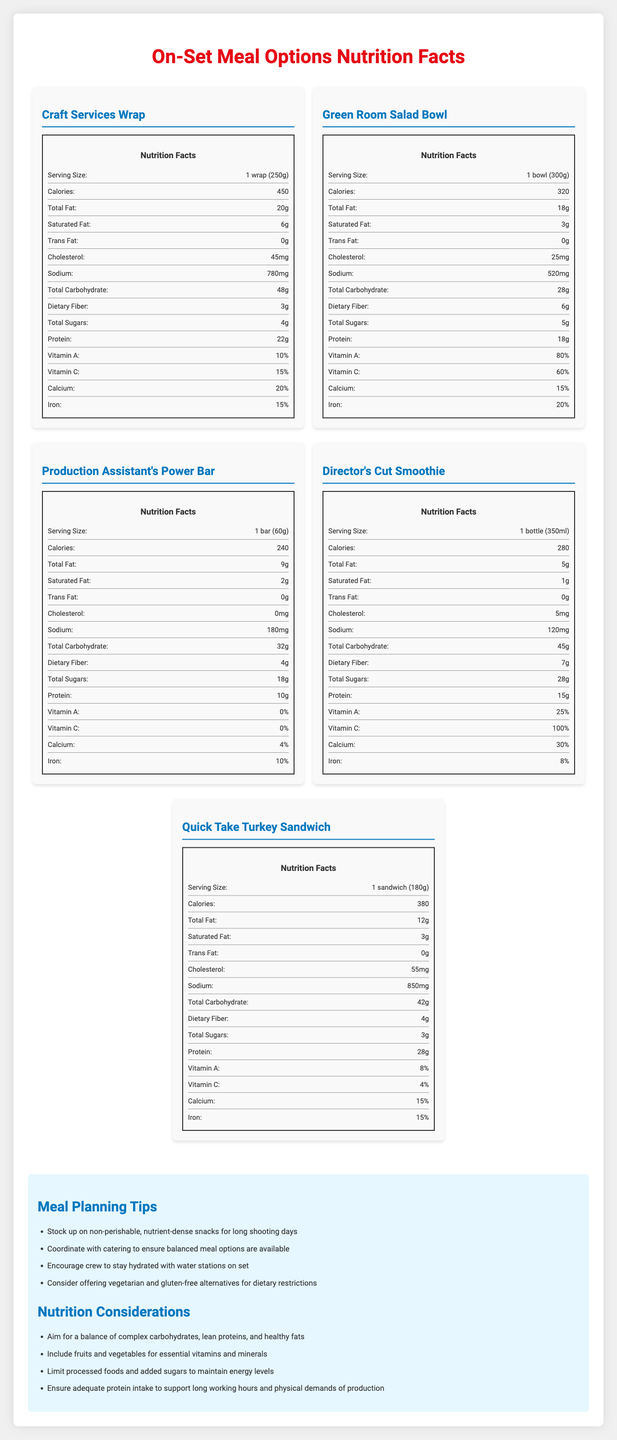what is the serving size of the "Craft Services Wrap"? The serving size is specified in the nutrition facts section for the "Craft Services Wrap".
Answer: 1 wrap (250g) How many grams of protein are in the "Green Room Salad Bowl"? The amount of protein is listed in the nutrition facts section for the "Green Room Salad Bowl".
Answer: 18g What is the total carbohydrate content of the "Production Assistant's Power Bar"? The nutrition facts section for the "Production Assistant's Power Bar" lists total carbohydrates as 32 grams.
Answer: 32g Which meal option has the highest amount of dietary fiber? The "Director's Cut Smoothie" has 7 grams of dietary fiber, which is the highest among the meal options listed.
Answer: Director's Cut Smoothie How much Vitamin C is in the "Quick Take Turkey Sandwich"? The nutrition facts section for the "Quick Take Turkey Sandwich" lists Vitamin C as 4%.
Answer: 4% Which meal option has the lowest calorie count? "Green Room Salad Bowl" with 320 calories has the lowest calorie count among the listed meal options.
Answer: Green Room Salad Bowl What is the cholesterol content in the "Craft Services Wrap"? The nutrition facts section for the "Craft Services Wrap" lists cholesterol as 45 mg.
Answer: 45mg Which meal option contains the least amount of sodium? A. Craft Services Wrap B. Green Room Salad Bowl C. Production Assistant's Power Bar D. Director's Cut Smoothie The "Director's Cut Smoothie" has the least sodium at 120 mg.
Answer: D Which meal option has the highest amount of total sugars? A. Craft Services Wrap B. Green Room Salad Bowl C. Production Assistant's Power Bar D. Director's Cut Smoothie The "Director's Cut Smoothie" has the highest total sugars at 28 grams.
Answer: D Does the "Production Assistant's Power Bar" contain any trans fat? The nutrition facts section states that the "Production Assistant's Power Bar" has 0 grams of trans fat.
Answer: No Summarize the main idea of the document. The document focuses on several meal options, listing their nutritional information like calories, fats, carbohydrates, and vitamins. It also includes general tips for meal planning and maintaining balanced nutrition on set.
Answer: The document provides detailed nutrition facts for various on-set meal options available during production, along with tips for meal planning and general nutrition considerations. Which meal option has the highest percentage of Vitamin A? The "Green Room Salad Bowl" has the highest percentage of Vitamin A at 80%.
Answer: Green Room Salad Bowl What is the primary nutritional concern when choosing processed foods? The additional info section mentions that one should limit processed foods and added sugars to maintain energy levels.
Answer: Limit processed foods and added sugars to maintain energy levels How much iron is in the "Director's Cut Smoothie"? The nutrition facts section for the "Director's Cut Smoothie" lists iron as 8%.
Answer: 8% How often should meals on set include fruits and vegetables? The document does not specify how often meals should include fruits and vegetables but emphasizes their importance for essential vitamins and minerals.
Answer: Cannot be determined 